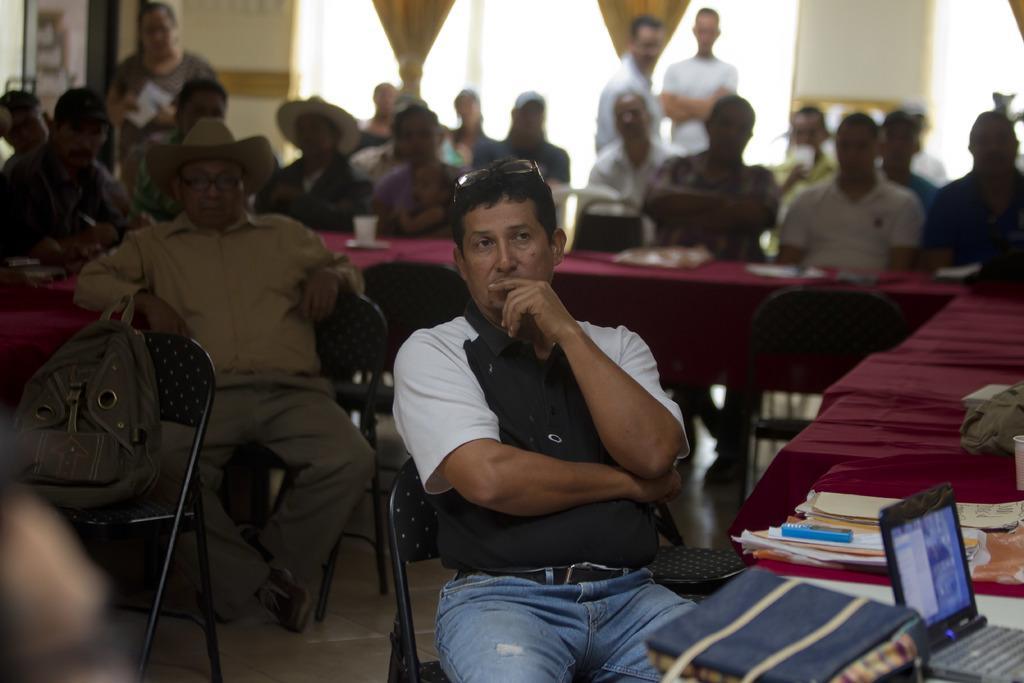Please provide a concise description of this image. In this image we can see this person is sitting on the chair. There are few papers, books, mobile phone, handbag and laptop on the table. We can see many people sitting on the chairs near table and standing in the background of the image. 